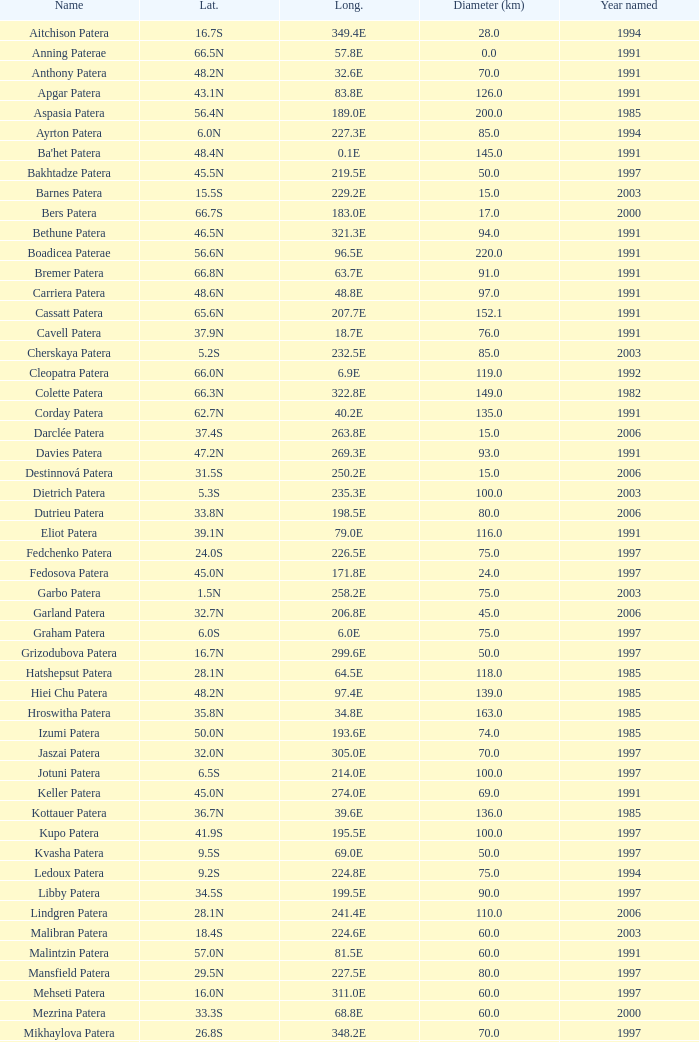What is Year Named, when Longitude is 227.5E? 1997.0. 